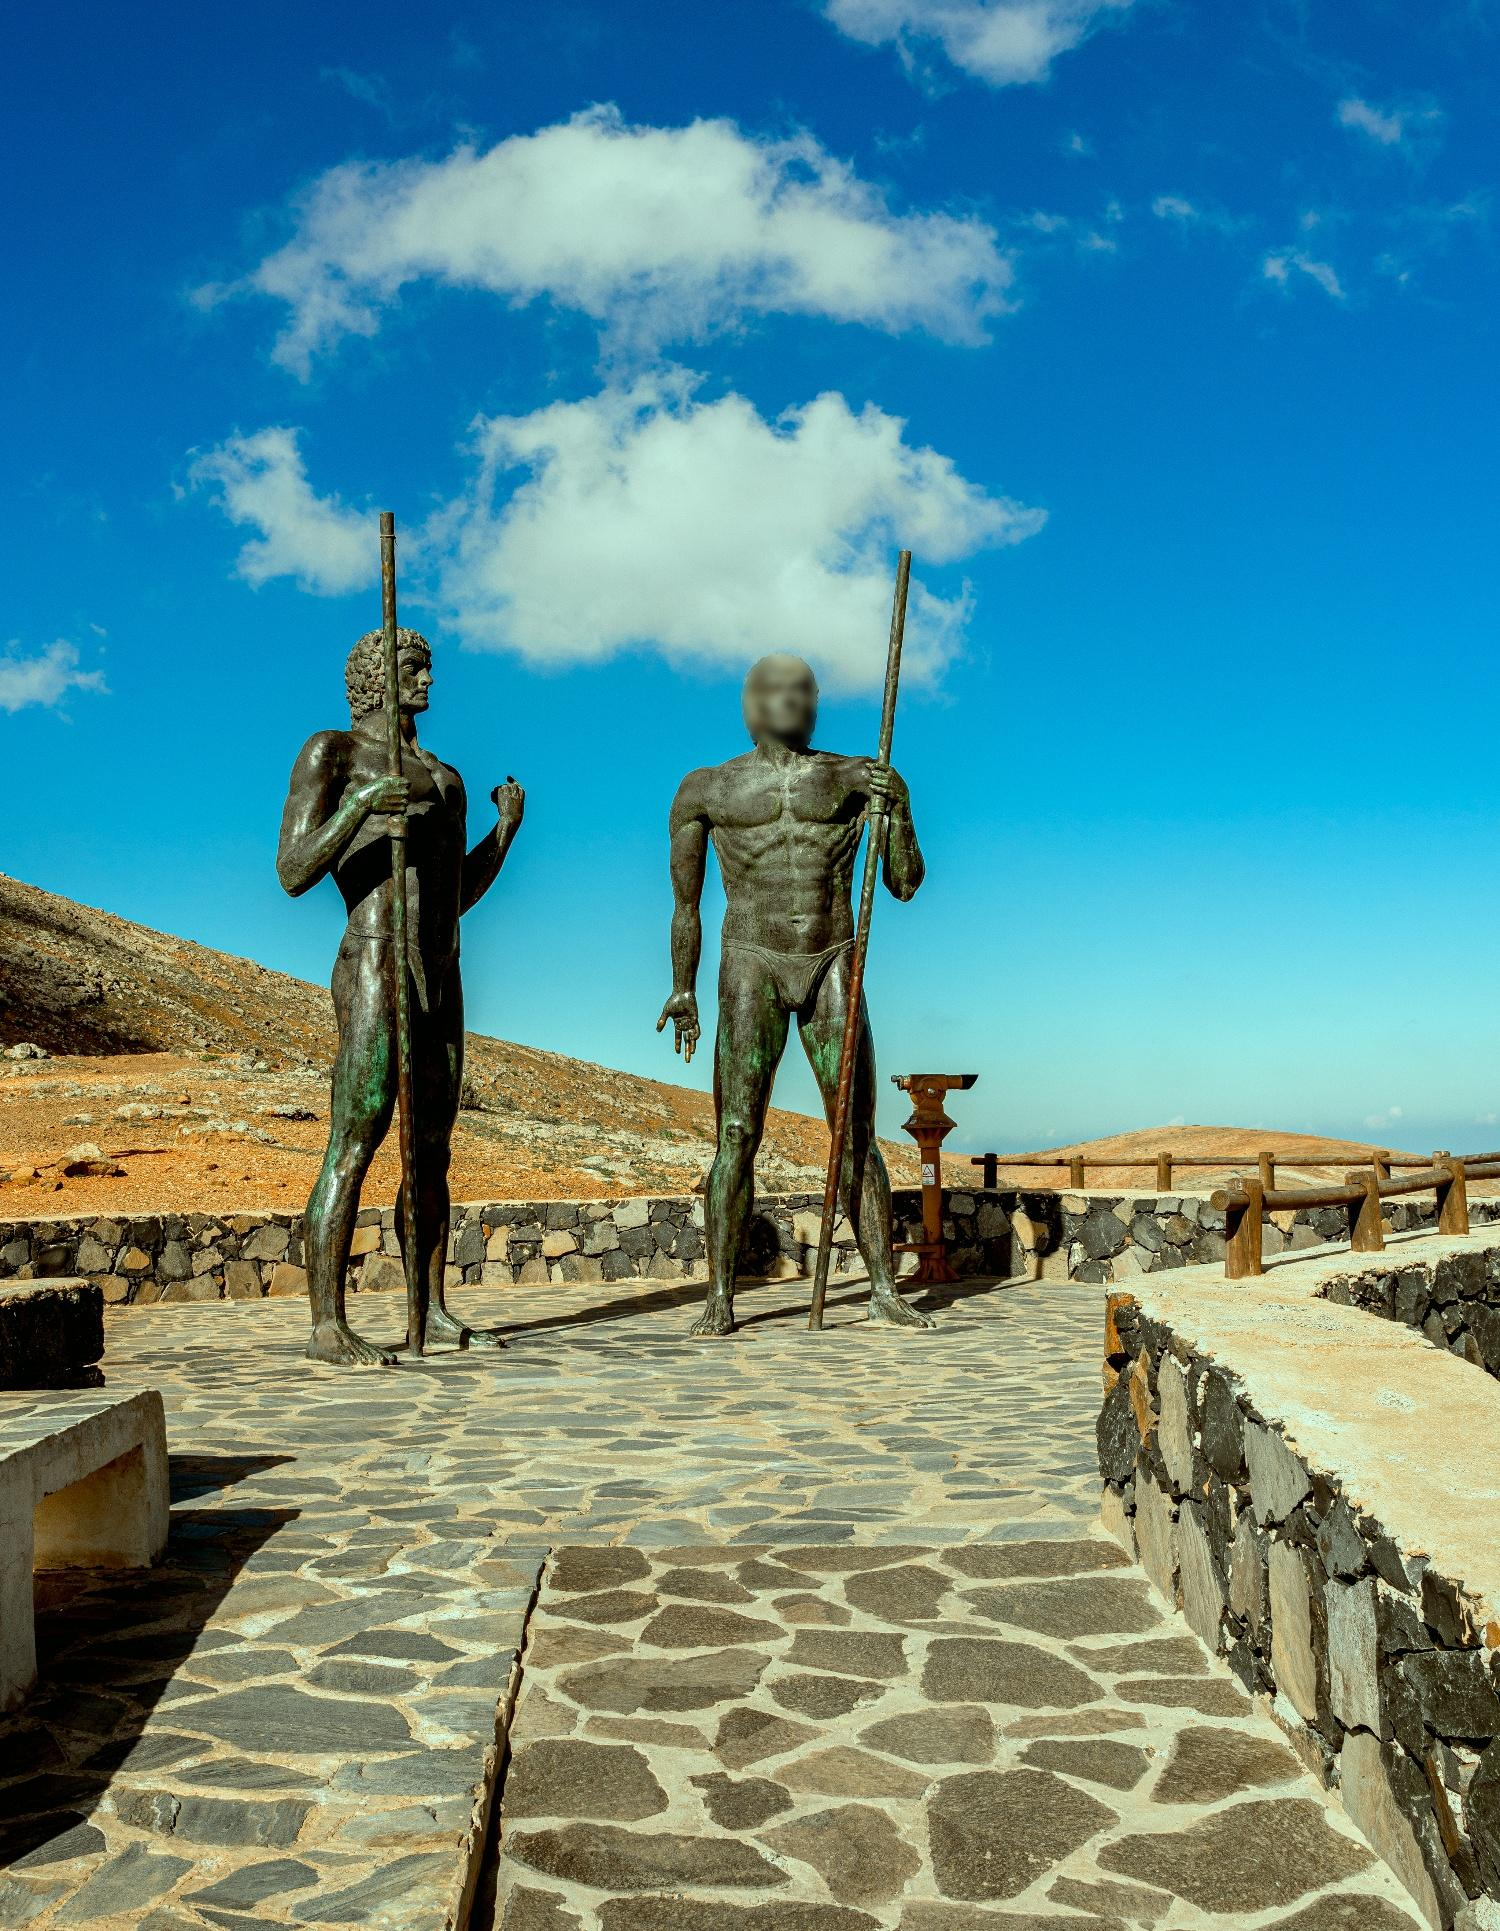What might be the historical or cultural significance of this location? This location, marked by the presence of the warrior statues, could potentially be a historical site commemorating ancient warriors or local heroes. The rugged terrain and the strategic positioning of the statues along the path suggest it might have been an area of historical conflicts or a boundary protecting a settlement. The artistic depiction and the placement in a seemingly remote area add to the solemnity and importance of the site, possibly serving as a tribute to bravery and resilience in local history. 